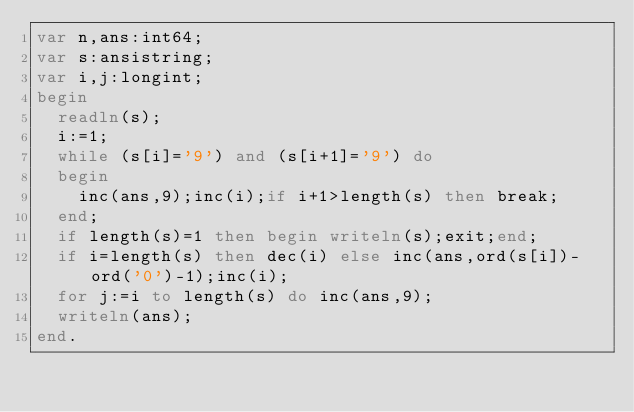<code> <loc_0><loc_0><loc_500><loc_500><_Pascal_>var n,ans:int64;
var s:ansistring;
var i,j:longint;
begin
  readln(s);
  i:=1;
  while (s[i]='9') and (s[i+1]='9') do
  begin
    inc(ans,9);inc(i);if i+1>length(s) then break;
  end;
  if length(s)=1 then begin writeln(s);exit;end;
  if i=length(s) then dec(i) else inc(ans,ord(s[i])-ord('0')-1);inc(i);
  for j:=i to length(s) do inc(ans,9);
  writeln(ans);
end.</code> 